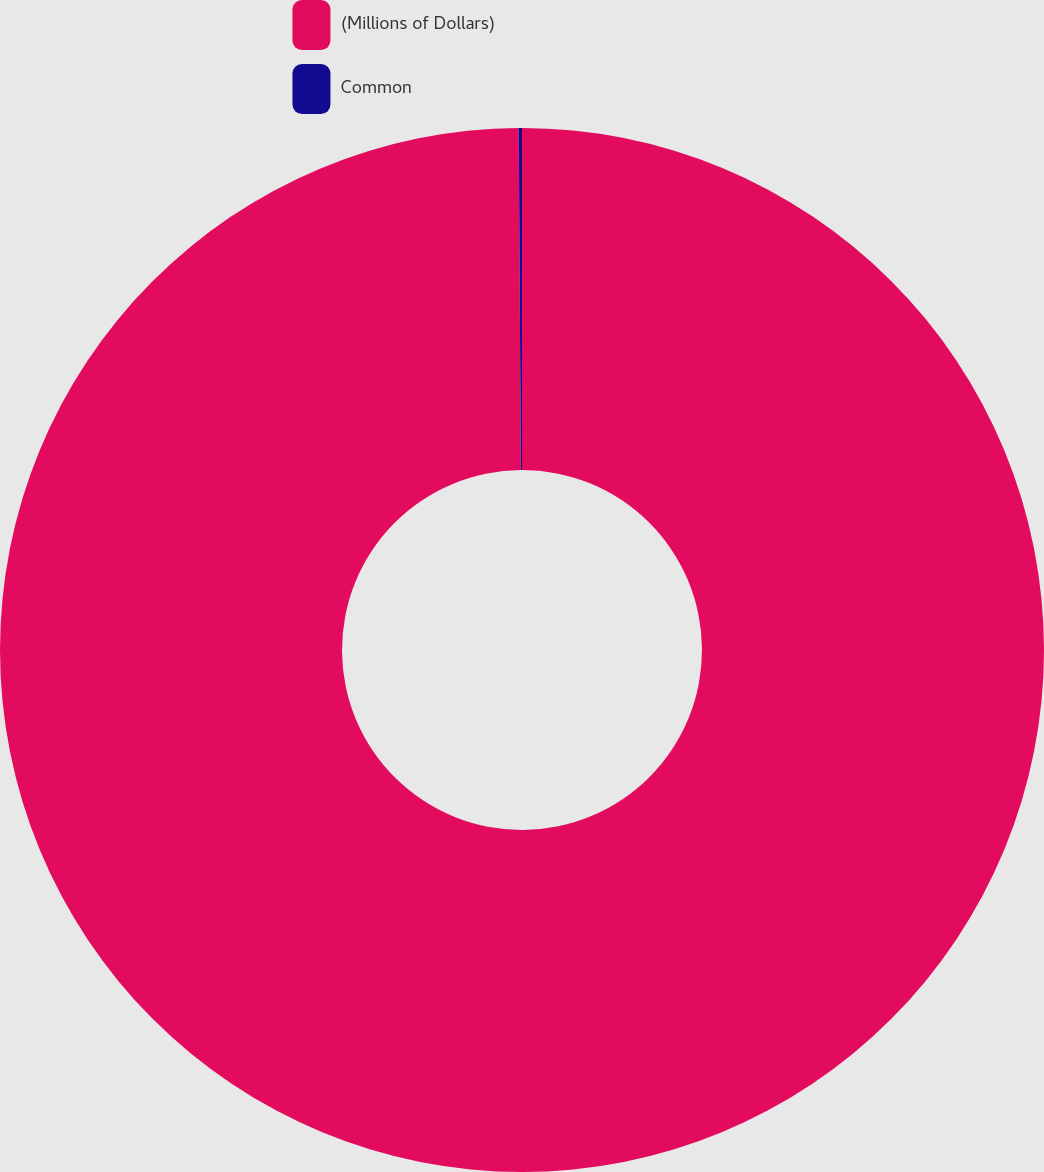Convert chart. <chart><loc_0><loc_0><loc_500><loc_500><pie_chart><fcel>(Millions of Dollars)<fcel>Common<nl><fcel>99.9%<fcel>0.1%<nl></chart> 